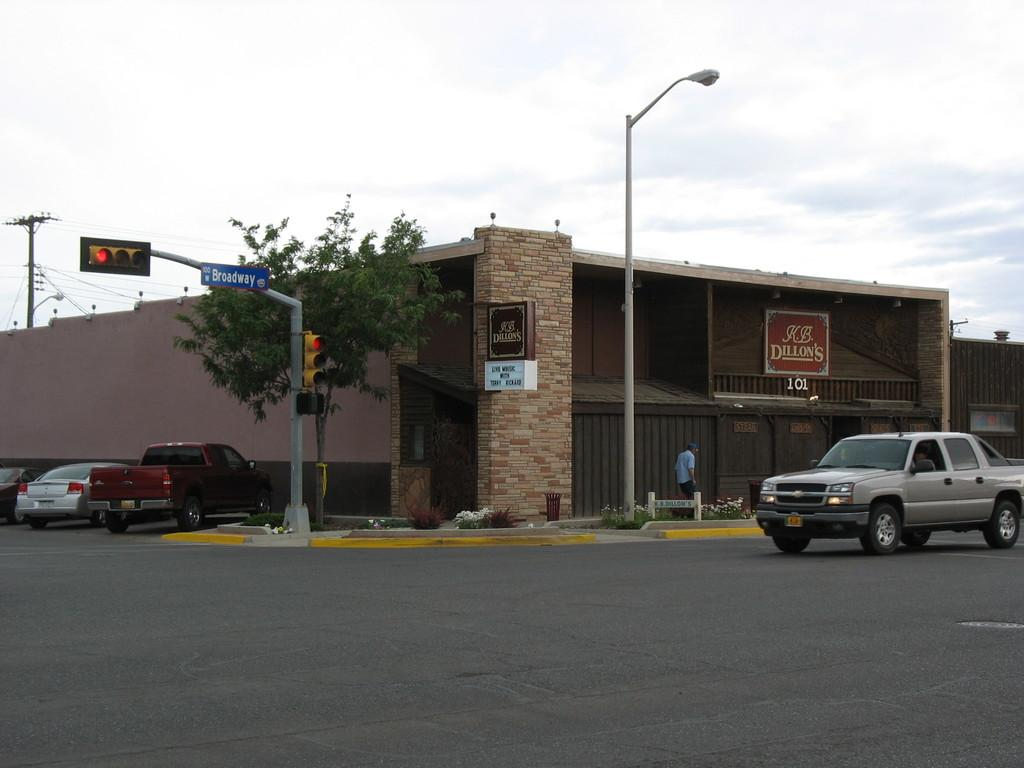What is located on the right side of the image? There is a vehicle on the road in the right corner of the image. What can be seen in the background of the image? There is a building, a tree, and a traffic light in the background of the image. Are there any other vehicles visible in the image? Yes, there are other vehicles in the background of the image. What type of marble is being used to pave the road in the image? There is no marble visible in the image; the road appears to be paved with a different material. Can you see any boots in the image? There are no boots present in the image. 